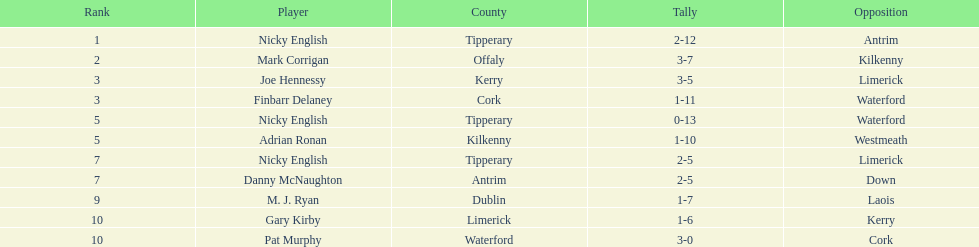What player got 10 total points in their game? M. J. Ryan. 